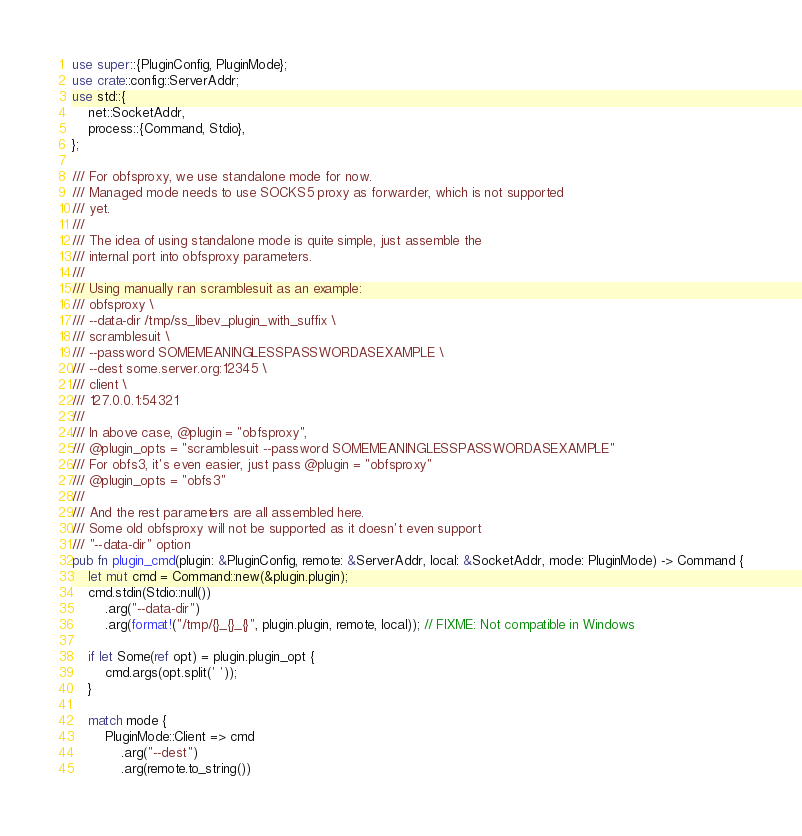Convert code to text. <code><loc_0><loc_0><loc_500><loc_500><_Rust_>use super::{PluginConfig, PluginMode};
use crate::config::ServerAddr;
use std::{
    net::SocketAddr,
    process::{Command, Stdio},
};

/// For obfsproxy, we use standalone mode for now.
/// Managed mode needs to use SOCKS5 proxy as forwarder, which is not supported
/// yet.
///
/// The idea of using standalone mode is quite simple, just assemble the
/// internal port into obfsproxy parameters.
///
/// Using manually ran scramblesuit as an example:
/// obfsproxy \
/// --data-dir /tmp/ss_libev_plugin_with_suffix \
/// scramblesuit \
/// --password SOMEMEANINGLESSPASSWORDASEXAMPLE \
/// --dest some.server.org:12345 \
/// client \
/// 127.0.0.1:54321
///
/// In above case, @plugin = "obfsproxy",
/// @plugin_opts = "scramblesuit --password SOMEMEANINGLESSPASSWORDASEXAMPLE"
/// For obfs3, it's even easier, just pass @plugin = "obfsproxy"
/// @plugin_opts = "obfs3"
///
/// And the rest parameters are all assembled here.
/// Some old obfsproxy will not be supported as it doesn't even support
/// "--data-dir" option
pub fn plugin_cmd(plugin: &PluginConfig, remote: &ServerAddr, local: &SocketAddr, mode: PluginMode) -> Command {
    let mut cmd = Command::new(&plugin.plugin);
    cmd.stdin(Stdio::null())
        .arg("--data-dir")
        .arg(format!("/tmp/{}_{}_{}", plugin.plugin, remote, local)); // FIXME: Not compatible in Windows

    if let Some(ref opt) = plugin.plugin_opt {
        cmd.args(opt.split(' '));
    }

    match mode {
        PluginMode::Client => cmd
            .arg("--dest")
            .arg(remote.to_string())</code> 